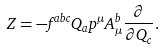Convert formula to latex. <formula><loc_0><loc_0><loc_500><loc_500>Z = - f ^ { a b c } Q _ { a } p ^ { \mu } A _ { \mu } ^ { b } \frac { \partial } { \partial Q _ { c } } .</formula> 